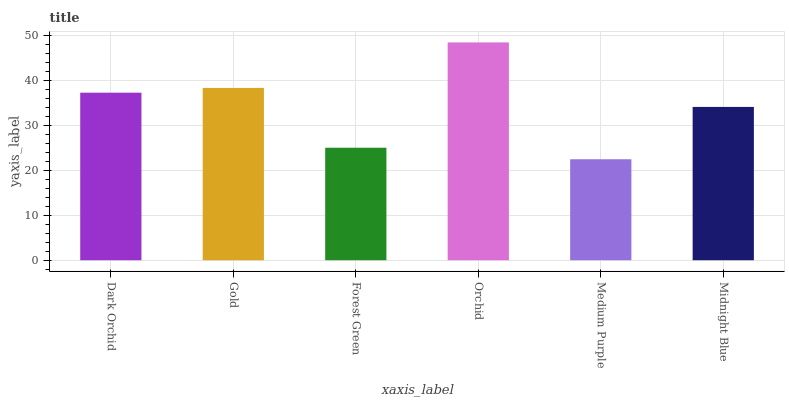Is Medium Purple the minimum?
Answer yes or no. Yes. Is Orchid the maximum?
Answer yes or no. Yes. Is Gold the minimum?
Answer yes or no. No. Is Gold the maximum?
Answer yes or no. No. Is Gold greater than Dark Orchid?
Answer yes or no. Yes. Is Dark Orchid less than Gold?
Answer yes or no. Yes. Is Dark Orchid greater than Gold?
Answer yes or no. No. Is Gold less than Dark Orchid?
Answer yes or no. No. Is Dark Orchid the high median?
Answer yes or no. Yes. Is Midnight Blue the low median?
Answer yes or no. Yes. Is Midnight Blue the high median?
Answer yes or no. No. Is Gold the low median?
Answer yes or no. No. 